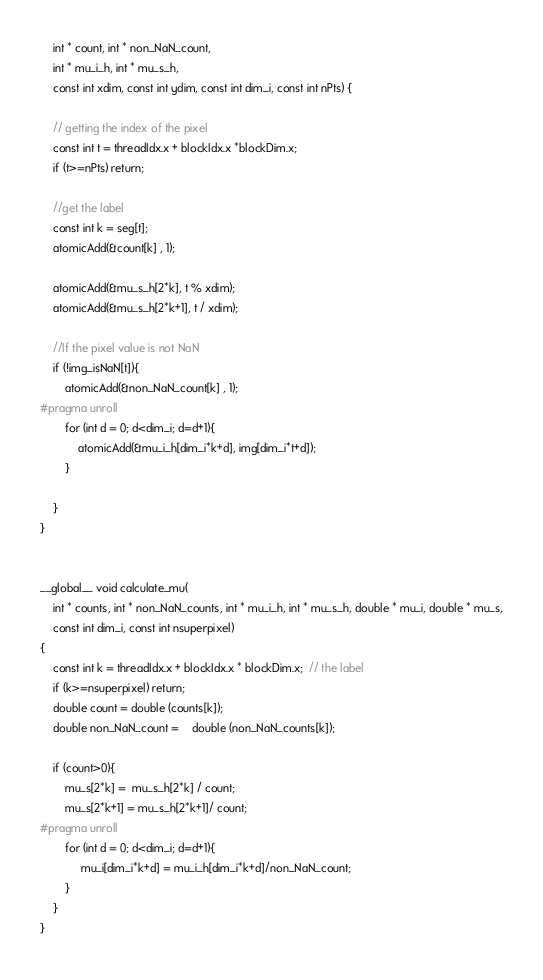Convert code to text. <code><loc_0><loc_0><loc_500><loc_500><_Cuda_>	int * count, int * non_NaN_count, 
	int * mu_i_h, int * mu_s_h,
	const int xdim, const int ydim, const int dim_i, const int nPts) {

	// getting the index of the pixel
	const int t = threadIdx.x + blockIdx.x *blockDim.x; 
	if (t>=nPts) return;

	//get the label
	const int k = seg[t];
	atomicAdd(&count[k] , 1);

	atomicAdd(&mu_s_h[2*k], t % xdim);
	atomicAdd(&mu_s_h[2*k+1], t / xdim);

	//If the pixel value is not NaN
	if (!img_isNaN[t]){
		atomicAdd(&non_NaN_count[k] , 1);
#pragma unroll 
		for (int d = 0; d<dim_i; d=d+1){
			atomicAdd(&mu_i_h[dim_i*k+d], img[dim_i*t+d]);
		}

	}
}


__global__ void calculate_mu(
	int * counts, int * non_NaN_counts, int * mu_i_h, int * mu_s_h, double * mu_i, double * mu_s,
	const int dim_i, const int nsuperpixel)
{
	const int k = threadIdx.x + blockIdx.x * blockDim.x;  // the label
	if (k>=nsuperpixel) return;
	double count = double (counts[k]);
	double non_NaN_count =	double (non_NaN_counts[k]);

	if (count>0){
		mu_s[2*k] =  mu_s_h[2*k] / count; 
	    mu_s[2*k+1] = mu_s_h[2*k+1]/ count; 
#pragma unroll 
	    for (int d = 0; d<dim_i; d=d+1){
	    	 mu_i[dim_i*k+d] = mu_i_h[dim_i*k+d]/non_NaN_count;
		}
	}
}</code> 